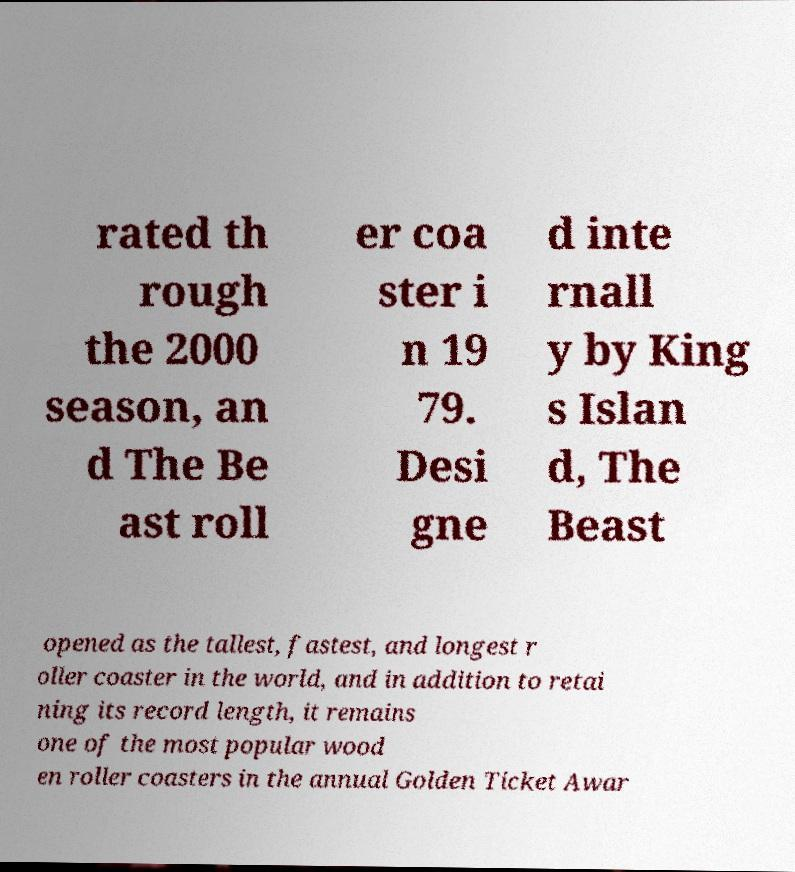Can you accurately transcribe the text from the provided image for me? rated th rough the 2000 season, an d The Be ast roll er coa ster i n 19 79. Desi gne d inte rnall y by King s Islan d, The Beast opened as the tallest, fastest, and longest r oller coaster in the world, and in addition to retai ning its record length, it remains one of the most popular wood en roller coasters in the annual Golden Ticket Awar 